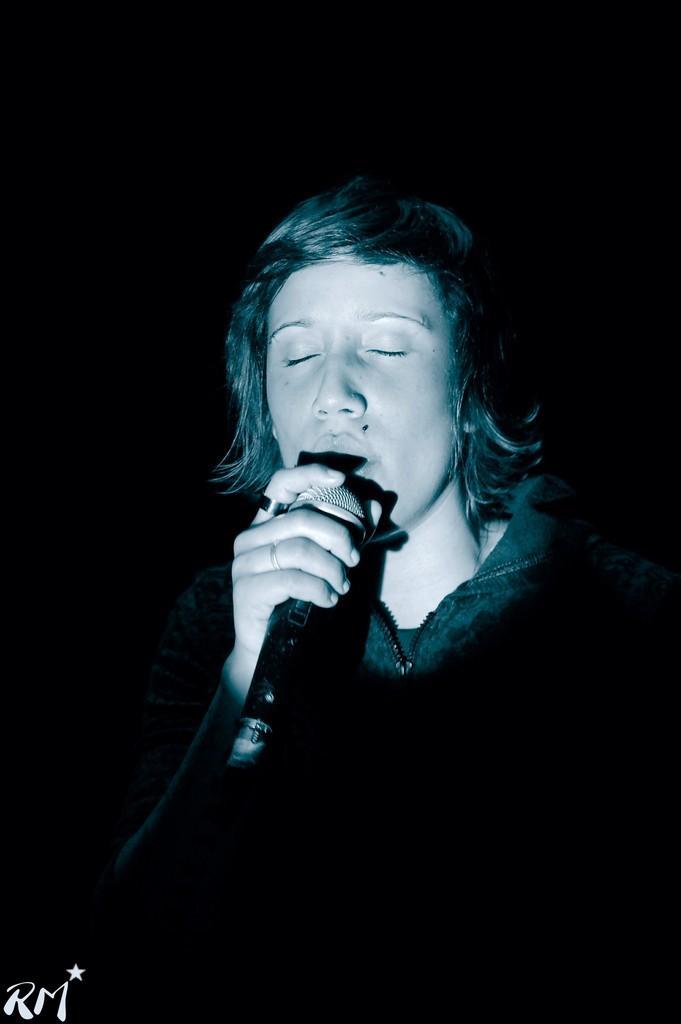In one or two sentences, can you explain what this image depicts? In this image there is a person holding mic in his hand. The background is dark. At the bottom right side of the image there is some text. 